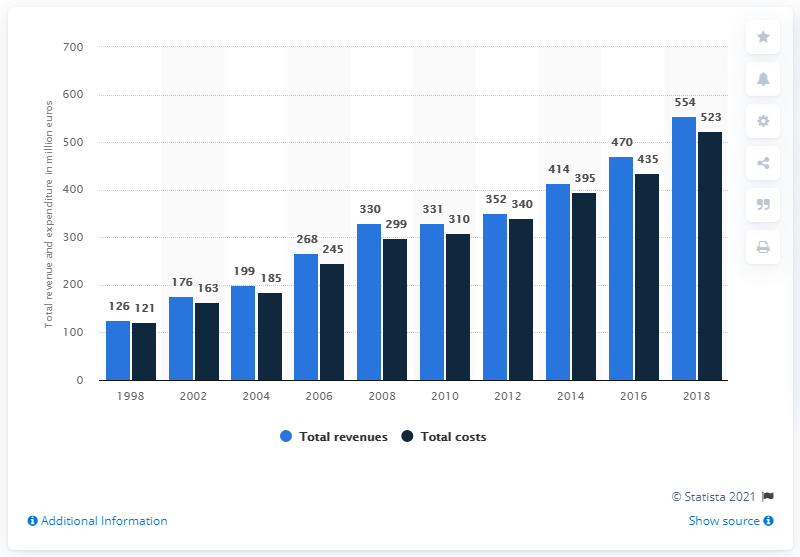Specify some key components in this picture. The year with the highest total revenue is 2021, with a total revenue of $10,251,949. The total revenues and costs in 2006 amounted to 513. 